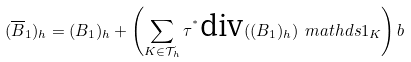<formula> <loc_0><loc_0><loc_500><loc_500>( \overline { B } _ { 1 } ) _ { h } = ( B _ { 1 } ) _ { h } + \left ( \sum _ { K \in \mathcal { T } _ { h } } \tau ^ { ^ { * } } \text {div} ( ( B _ { 1 } ) _ { h } ) \ m a t h d s { 1 } _ { K } \right ) b</formula> 